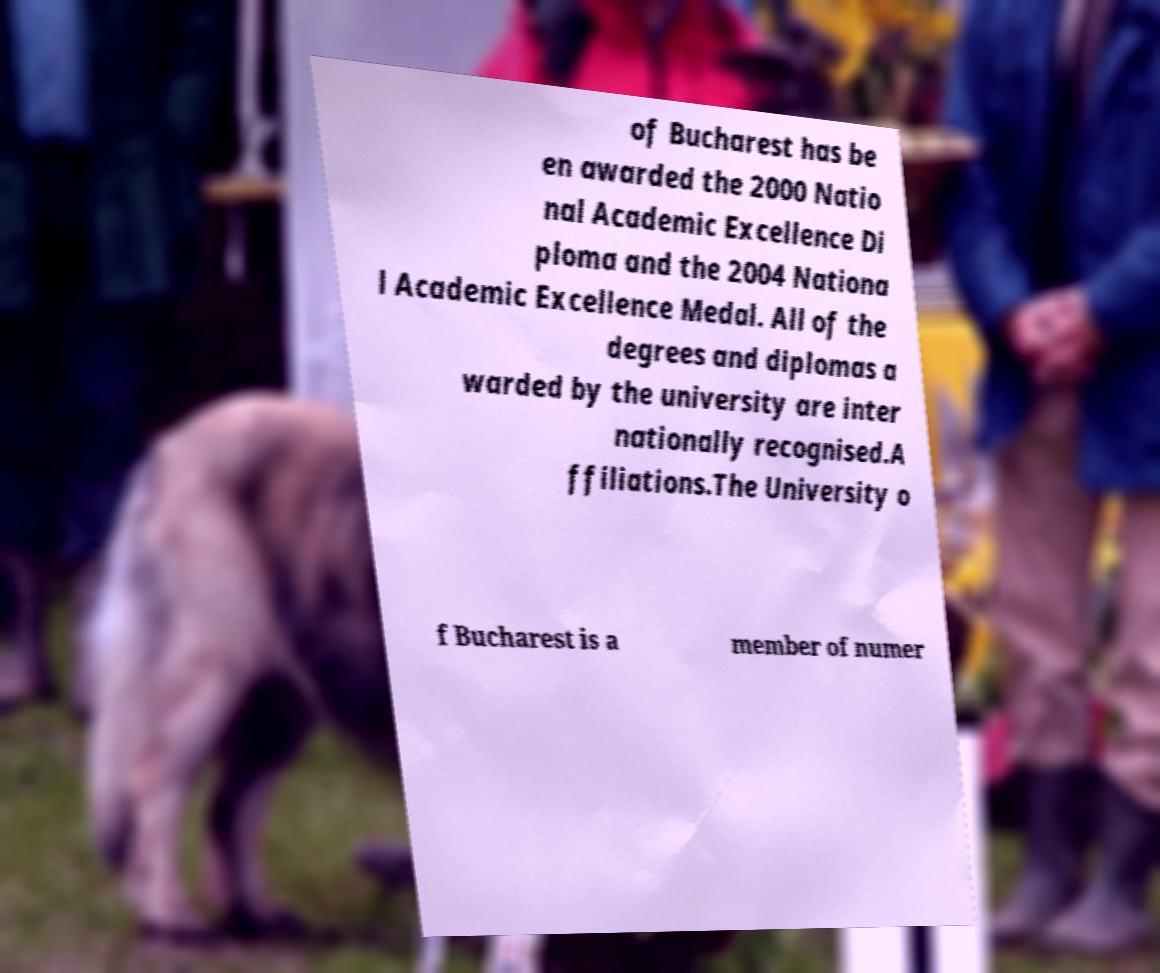Could you extract and type out the text from this image? of Bucharest has be en awarded the 2000 Natio nal Academic Excellence Di ploma and the 2004 Nationa l Academic Excellence Medal. All of the degrees and diplomas a warded by the university are inter nationally recognised.A ffiliations.The University o f Bucharest is a member of numer 